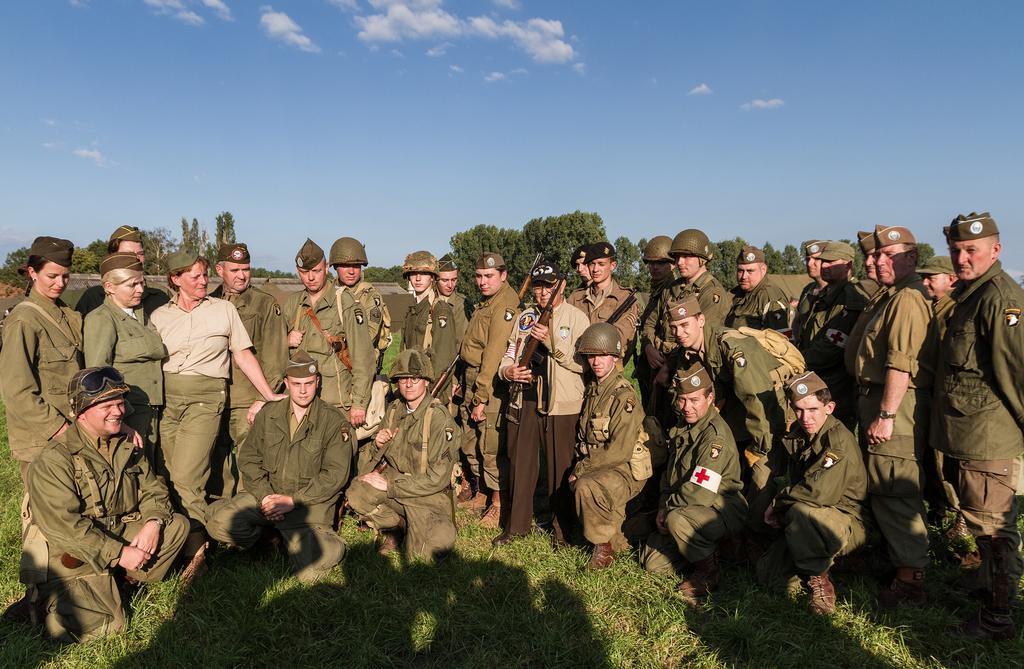Could you give a brief overview of what you see in this image? This picture describes about group of people, few people wore helmets and caps, in the background we can see few trees and clouds, and also we can see grass. 